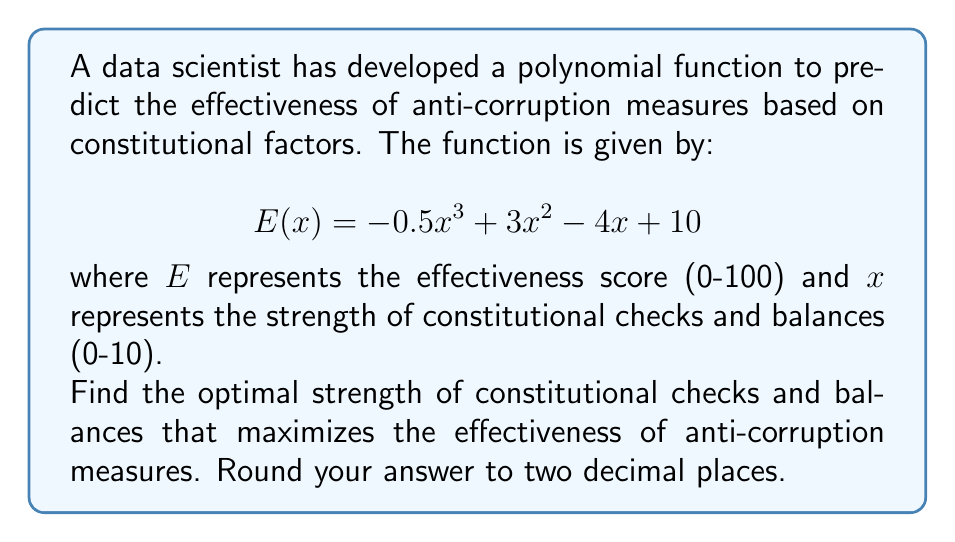Give your solution to this math problem. To find the optimal strength of constitutional checks and balances that maximizes the effectiveness, we need to find the maximum point of the polynomial function. This can be done by following these steps:

1. Find the derivative of the function:
   $$E'(x) = -1.5x^2 + 6x - 4$$

2. Set the derivative equal to zero and solve for x:
   $$-1.5x^2 + 6x - 4 = 0$$

3. This is a quadratic equation. We can solve it using the quadratic formula:
   $$x = \frac{-b \pm \sqrt{b^2 - 4ac}}{2a}$$
   where $a = -1.5$, $b = 6$, and $c = -4$

4. Substituting these values:
   $$x = \frac{-6 \pm \sqrt{36 - 4(-1.5)(-4)}}{2(-1.5)}$$
   $$x = \frac{-6 \pm \sqrt{36 - 24}}{-3}$$
   $$x = \frac{-6 \pm \sqrt{12}}{-3}$$
   $$x = \frac{-6 \pm 2\sqrt{3}}{-3}$$

5. This gives us two solutions:
   $$x_1 = \frac{-6 + 2\sqrt{3}}{-3} = 2 - \frac{2\sqrt{3}}{3} \approx 0.85$$
   $$x_2 = \frac{-6 - 2\sqrt{3}}{-3} = 2 + \frac{2\sqrt{3}}{3} \approx 3.15$$

6. To determine which of these is the maximum (rather than the minimum), we can check the second derivative:
   $$E''(x) = -3x + 6$$

7. Evaluating $E''(x)$ at $x_1$ and $x_2$:
   $$E''(0.85) \approx 3.45 > 0$$
   $$E''(3.15) \approx -3.45 < 0$$

8. Since $E''(3.15) < 0$, this corresponds to the maximum point.

Therefore, the optimal strength of constitutional checks and balances is approximately 3.15.
Answer: 3.15 